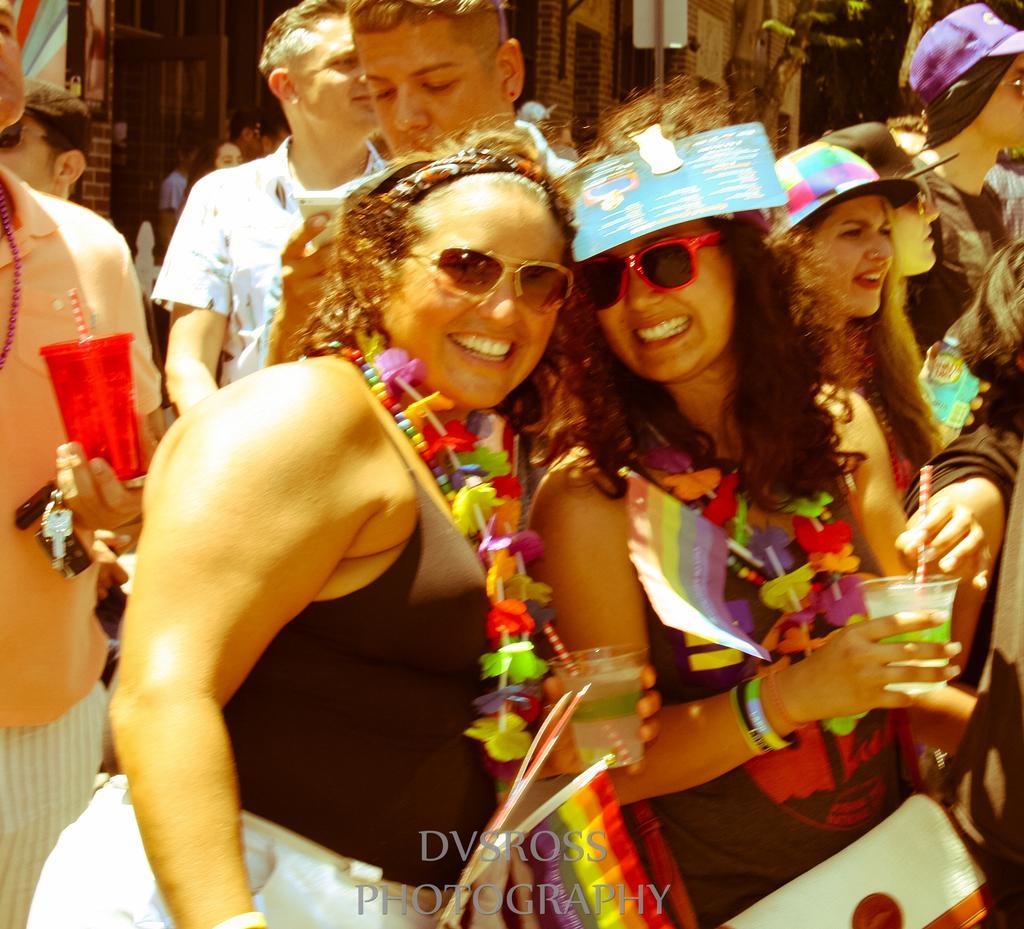Can you describe this image briefly? In this image I can see group of people. In front the person is holding a glass and I can also see the flag in red, orange, yellow and green color. Background I can see few stalls. 